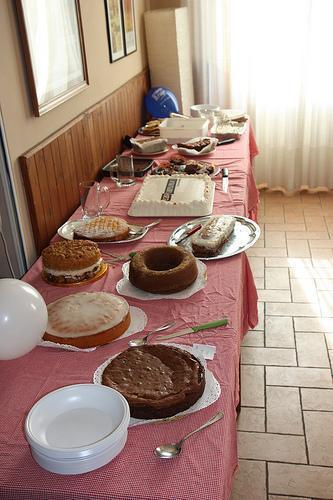How many balloons are in the picture?
Give a very brief answer. 2. 